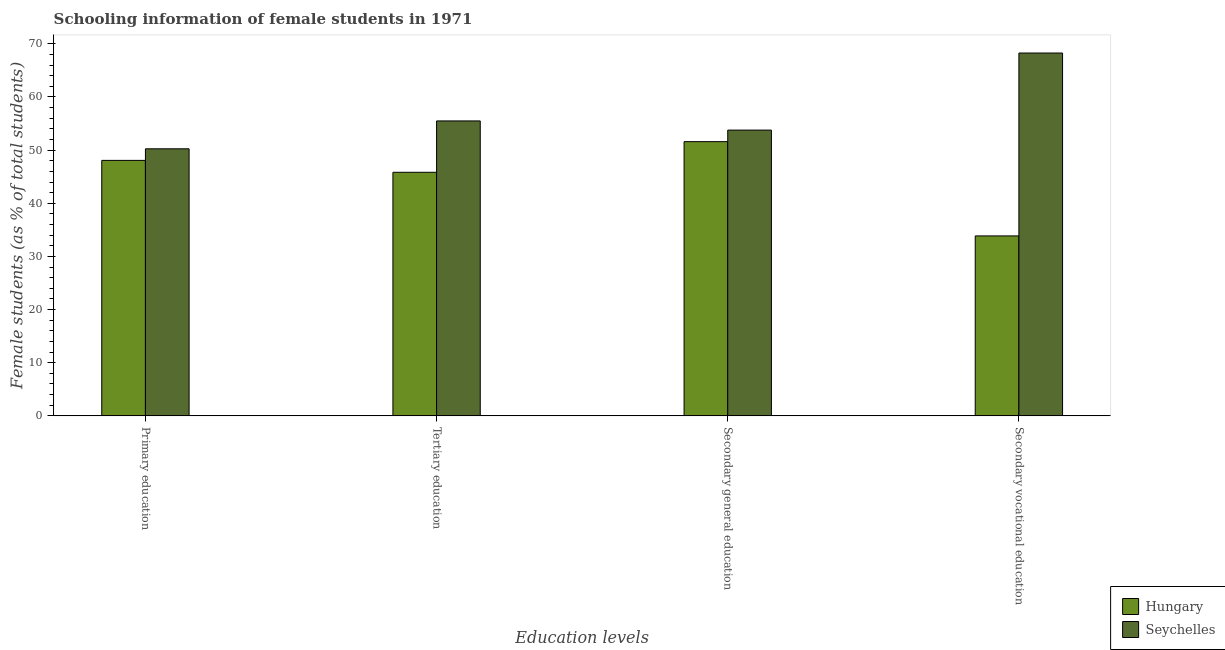How many different coloured bars are there?
Keep it short and to the point. 2. Are the number of bars per tick equal to the number of legend labels?
Ensure brevity in your answer.  Yes. What is the label of the 3rd group of bars from the left?
Provide a succinct answer. Secondary general education. What is the percentage of female students in primary education in Seychelles?
Give a very brief answer. 50.25. Across all countries, what is the maximum percentage of female students in secondary vocational education?
Make the answer very short. 68.27. Across all countries, what is the minimum percentage of female students in secondary vocational education?
Provide a succinct answer. 33.86. In which country was the percentage of female students in secondary vocational education maximum?
Give a very brief answer. Seychelles. In which country was the percentage of female students in primary education minimum?
Give a very brief answer. Hungary. What is the total percentage of female students in tertiary education in the graph?
Make the answer very short. 101.32. What is the difference between the percentage of female students in secondary vocational education in Hungary and that in Seychelles?
Offer a terse response. -34.41. What is the difference between the percentage of female students in tertiary education in Hungary and the percentage of female students in secondary education in Seychelles?
Make the answer very short. -7.94. What is the average percentage of female students in secondary education per country?
Give a very brief answer. 52.68. What is the difference between the percentage of female students in primary education and percentage of female students in secondary education in Hungary?
Keep it short and to the point. -3.52. What is the ratio of the percentage of female students in primary education in Seychelles to that in Hungary?
Provide a succinct answer. 1.05. Is the percentage of female students in secondary vocational education in Seychelles less than that in Hungary?
Offer a very short reply. No. What is the difference between the highest and the second highest percentage of female students in secondary education?
Your answer should be compact. 2.17. What is the difference between the highest and the lowest percentage of female students in secondary vocational education?
Ensure brevity in your answer.  34.41. In how many countries, is the percentage of female students in primary education greater than the average percentage of female students in primary education taken over all countries?
Make the answer very short. 1. What does the 2nd bar from the left in Secondary vocational education represents?
Keep it short and to the point. Seychelles. What does the 2nd bar from the right in Tertiary education represents?
Ensure brevity in your answer.  Hungary. Is it the case that in every country, the sum of the percentage of female students in primary education and percentage of female students in tertiary education is greater than the percentage of female students in secondary education?
Your answer should be very brief. Yes. How many bars are there?
Provide a short and direct response. 8. Does the graph contain any zero values?
Offer a terse response. No. Where does the legend appear in the graph?
Your answer should be very brief. Bottom right. How many legend labels are there?
Provide a succinct answer. 2. How are the legend labels stacked?
Offer a terse response. Vertical. What is the title of the graph?
Provide a short and direct response. Schooling information of female students in 1971. What is the label or title of the X-axis?
Keep it short and to the point. Education levels. What is the label or title of the Y-axis?
Your answer should be very brief. Female students (as % of total students). What is the Female students (as % of total students) of Hungary in Primary education?
Make the answer very short. 48.07. What is the Female students (as % of total students) of Seychelles in Primary education?
Offer a very short reply. 50.25. What is the Female students (as % of total students) of Hungary in Tertiary education?
Give a very brief answer. 45.83. What is the Female students (as % of total students) in Seychelles in Tertiary education?
Your response must be concise. 55.49. What is the Female students (as % of total students) in Hungary in Secondary general education?
Give a very brief answer. 51.59. What is the Female students (as % of total students) in Seychelles in Secondary general education?
Give a very brief answer. 53.77. What is the Female students (as % of total students) of Hungary in Secondary vocational education?
Provide a succinct answer. 33.86. What is the Female students (as % of total students) in Seychelles in Secondary vocational education?
Give a very brief answer. 68.27. Across all Education levels, what is the maximum Female students (as % of total students) in Hungary?
Your answer should be compact. 51.59. Across all Education levels, what is the maximum Female students (as % of total students) of Seychelles?
Your answer should be compact. 68.27. Across all Education levels, what is the minimum Female students (as % of total students) in Hungary?
Your response must be concise. 33.86. Across all Education levels, what is the minimum Female students (as % of total students) of Seychelles?
Your response must be concise. 50.25. What is the total Female students (as % of total students) of Hungary in the graph?
Keep it short and to the point. 179.35. What is the total Female students (as % of total students) in Seychelles in the graph?
Your answer should be very brief. 227.77. What is the difference between the Female students (as % of total students) of Hungary in Primary education and that in Tertiary education?
Give a very brief answer. 2.24. What is the difference between the Female students (as % of total students) in Seychelles in Primary education and that in Tertiary education?
Provide a succinct answer. -5.25. What is the difference between the Female students (as % of total students) of Hungary in Primary education and that in Secondary general education?
Give a very brief answer. -3.52. What is the difference between the Female students (as % of total students) of Seychelles in Primary education and that in Secondary general education?
Your answer should be compact. -3.52. What is the difference between the Female students (as % of total students) in Hungary in Primary education and that in Secondary vocational education?
Make the answer very short. 14.21. What is the difference between the Female students (as % of total students) of Seychelles in Primary education and that in Secondary vocational education?
Keep it short and to the point. -18.02. What is the difference between the Female students (as % of total students) in Hungary in Tertiary education and that in Secondary general education?
Give a very brief answer. -5.76. What is the difference between the Female students (as % of total students) of Seychelles in Tertiary education and that in Secondary general education?
Offer a very short reply. 1.73. What is the difference between the Female students (as % of total students) of Hungary in Tertiary education and that in Secondary vocational education?
Offer a very short reply. 11.97. What is the difference between the Female students (as % of total students) of Seychelles in Tertiary education and that in Secondary vocational education?
Keep it short and to the point. -12.78. What is the difference between the Female students (as % of total students) in Hungary in Secondary general education and that in Secondary vocational education?
Make the answer very short. 17.73. What is the difference between the Female students (as % of total students) in Seychelles in Secondary general education and that in Secondary vocational education?
Your response must be concise. -14.5. What is the difference between the Female students (as % of total students) in Hungary in Primary education and the Female students (as % of total students) in Seychelles in Tertiary education?
Provide a short and direct response. -7.42. What is the difference between the Female students (as % of total students) in Hungary in Primary education and the Female students (as % of total students) in Seychelles in Secondary general education?
Make the answer very short. -5.7. What is the difference between the Female students (as % of total students) of Hungary in Primary education and the Female students (as % of total students) of Seychelles in Secondary vocational education?
Ensure brevity in your answer.  -20.2. What is the difference between the Female students (as % of total students) of Hungary in Tertiary education and the Female students (as % of total students) of Seychelles in Secondary general education?
Offer a very short reply. -7.94. What is the difference between the Female students (as % of total students) in Hungary in Tertiary education and the Female students (as % of total students) in Seychelles in Secondary vocational education?
Your answer should be compact. -22.44. What is the difference between the Female students (as % of total students) of Hungary in Secondary general education and the Female students (as % of total students) of Seychelles in Secondary vocational education?
Ensure brevity in your answer.  -16.68. What is the average Female students (as % of total students) of Hungary per Education levels?
Provide a succinct answer. 44.84. What is the average Female students (as % of total students) in Seychelles per Education levels?
Ensure brevity in your answer.  56.94. What is the difference between the Female students (as % of total students) in Hungary and Female students (as % of total students) in Seychelles in Primary education?
Provide a succinct answer. -2.18. What is the difference between the Female students (as % of total students) of Hungary and Female students (as % of total students) of Seychelles in Tertiary education?
Give a very brief answer. -9.66. What is the difference between the Female students (as % of total students) in Hungary and Female students (as % of total students) in Seychelles in Secondary general education?
Provide a short and direct response. -2.17. What is the difference between the Female students (as % of total students) in Hungary and Female students (as % of total students) in Seychelles in Secondary vocational education?
Keep it short and to the point. -34.41. What is the ratio of the Female students (as % of total students) in Hungary in Primary education to that in Tertiary education?
Keep it short and to the point. 1.05. What is the ratio of the Female students (as % of total students) of Seychelles in Primary education to that in Tertiary education?
Provide a succinct answer. 0.91. What is the ratio of the Female students (as % of total students) of Hungary in Primary education to that in Secondary general education?
Give a very brief answer. 0.93. What is the ratio of the Female students (as % of total students) of Seychelles in Primary education to that in Secondary general education?
Offer a very short reply. 0.93. What is the ratio of the Female students (as % of total students) in Hungary in Primary education to that in Secondary vocational education?
Provide a succinct answer. 1.42. What is the ratio of the Female students (as % of total students) of Seychelles in Primary education to that in Secondary vocational education?
Offer a very short reply. 0.74. What is the ratio of the Female students (as % of total students) of Hungary in Tertiary education to that in Secondary general education?
Give a very brief answer. 0.89. What is the ratio of the Female students (as % of total students) of Seychelles in Tertiary education to that in Secondary general education?
Provide a succinct answer. 1.03. What is the ratio of the Female students (as % of total students) of Hungary in Tertiary education to that in Secondary vocational education?
Keep it short and to the point. 1.35. What is the ratio of the Female students (as % of total students) of Seychelles in Tertiary education to that in Secondary vocational education?
Keep it short and to the point. 0.81. What is the ratio of the Female students (as % of total students) in Hungary in Secondary general education to that in Secondary vocational education?
Your response must be concise. 1.52. What is the ratio of the Female students (as % of total students) in Seychelles in Secondary general education to that in Secondary vocational education?
Offer a very short reply. 0.79. What is the difference between the highest and the second highest Female students (as % of total students) of Hungary?
Your response must be concise. 3.52. What is the difference between the highest and the second highest Female students (as % of total students) in Seychelles?
Keep it short and to the point. 12.78. What is the difference between the highest and the lowest Female students (as % of total students) in Hungary?
Give a very brief answer. 17.73. What is the difference between the highest and the lowest Female students (as % of total students) in Seychelles?
Your answer should be very brief. 18.02. 